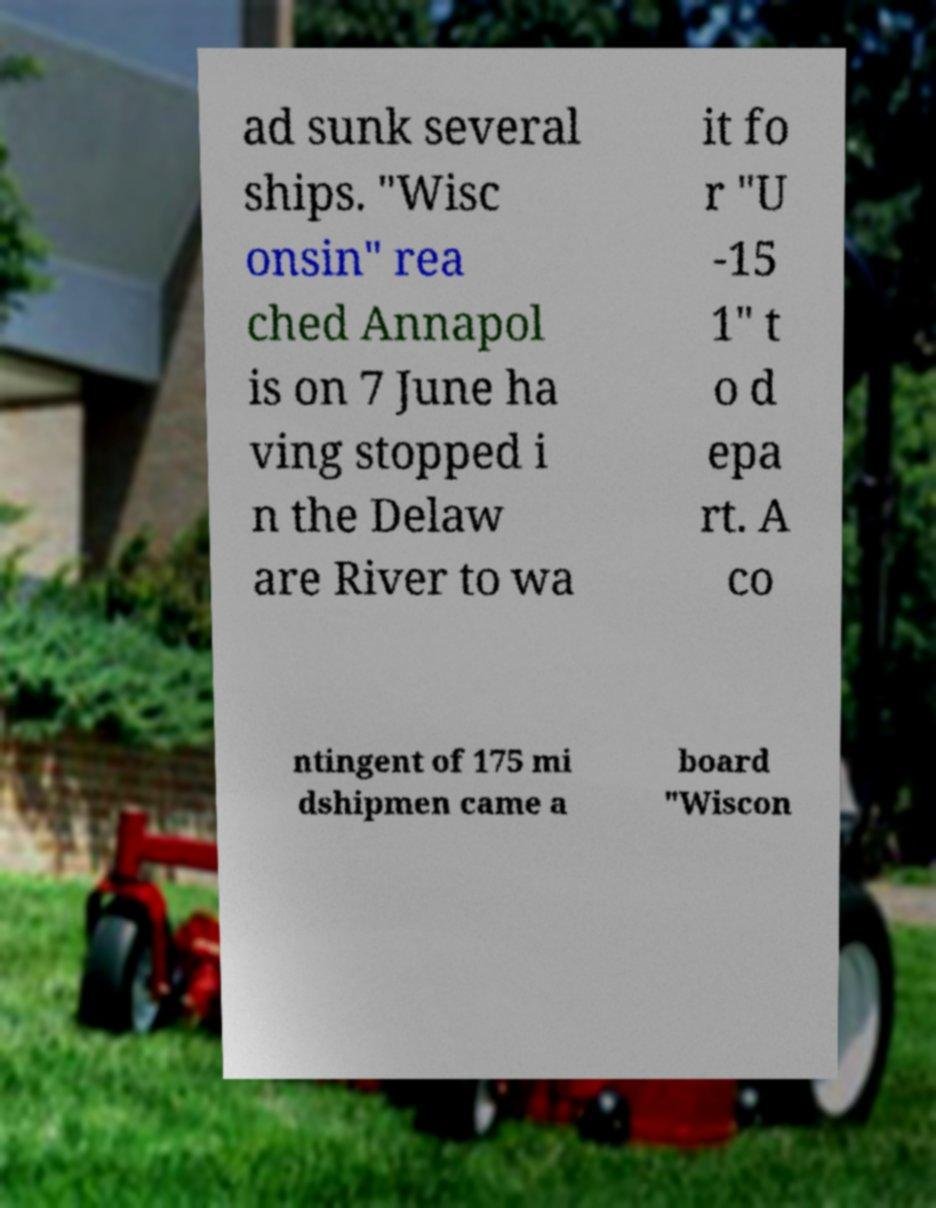Could you assist in decoding the text presented in this image and type it out clearly? ad sunk several ships. "Wisc onsin" rea ched Annapol is on 7 June ha ving stopped i n the Delaw are River to wa it fo r "U -15 1" t o d epa rt. A co ntingent of 175 mi dshipmen came a board "Wiscon 